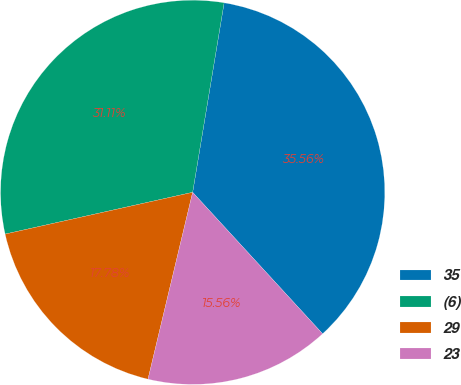Convert chart. <chart><loc_0><loc_0><loc_500><loc_500><pie_chart><fcel>35<fcel>(6)<fcel>29<fcel>23<nl><fcel>35.56%<fcel>31.11%<fcel>17.78%<fcel>15.56%<nl></chart> 